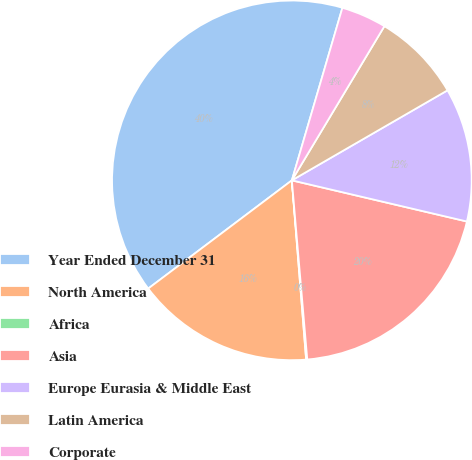<chart> <loc_0><loc_0><loc_500><loc_500><pie_chart><fcel>Year Ended December 31<fcel>North America<fcel>Africa<fcel>Asia<fcel>Europe Eurasia & Middle East<fcel>Latin America<fcel>Corporate<nl><fcel>39.81%<fcel>15.99%<fcel>0.1%<fcel>19.96%<fcel>12.02%<fcel>8.05%<fcel>4.07%<nl></chart> 